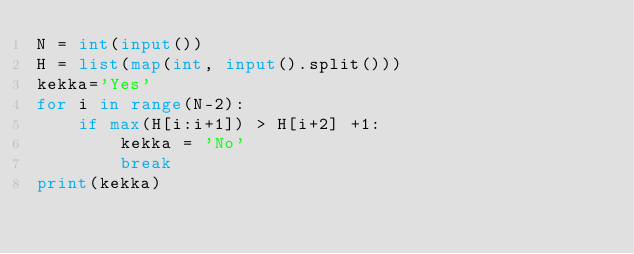Convert code to text. <code><loc_0><loc_0><loc_500><loc_500><_Python_>N = int(input())
H = list(map(int, input().split()))
kekka='Yes'
for i in range(N-2):
    if max(H[i:i+1]) > H[i+2] +1:
        kekka = 'No'
        break
print(kekka)</code> 